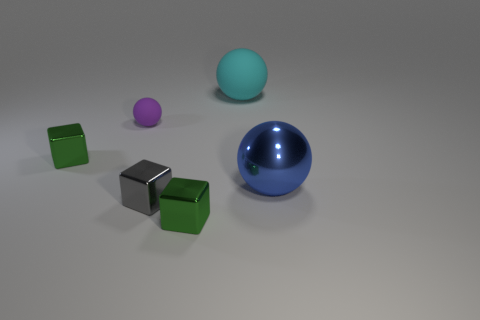Subtract all large balls. How many balls are left? 1 Subtract all gray blocks. How many blocks are left? 2 Subtract all brown cylinders. Subtract all gray metal cubes. How many objects are left? 5 Add 1 balls. How many balls are left? 4 Add 6 small blue cubes. How many small blue cubes exist? 6 Add 1 matte objects. How many objects exist? 7 Subtract 2 green blocks. How many objects are left? 4 Subtract 2 spheres. How many spheres are left? 1 Subtract all brown cubes. Subtract all purple spheres. How many cubes are left? 3 Subtract all green cylinders. How many gray cubes are left? 1 